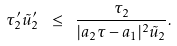Convert formula to latex. <formula><loc_0><loc_0><loc_500><loc_500>\tau ^ { \prime } _ { 2 } \tilde { u } ^ { \prime } _ { 2 } \ \leq \ \frac { \tau _ { 2 } } { | a _ { 2 } \tau - a _ { 1 } | ^ { 2 } \tilde { u } _ { 2 } } .</formula> 